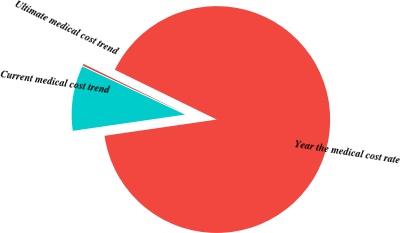Convert chart to OTSL. <chart><loc_0><loc_0><loc_500><loc_500><pie_chart><fcel>Current medical cost trend<fcel>Ultimate medical cost trend<fcel>Year the medical cost rate<nl><fcel>9.27%<fcel>0.25%<fcel>90.48%<nl></chart> 